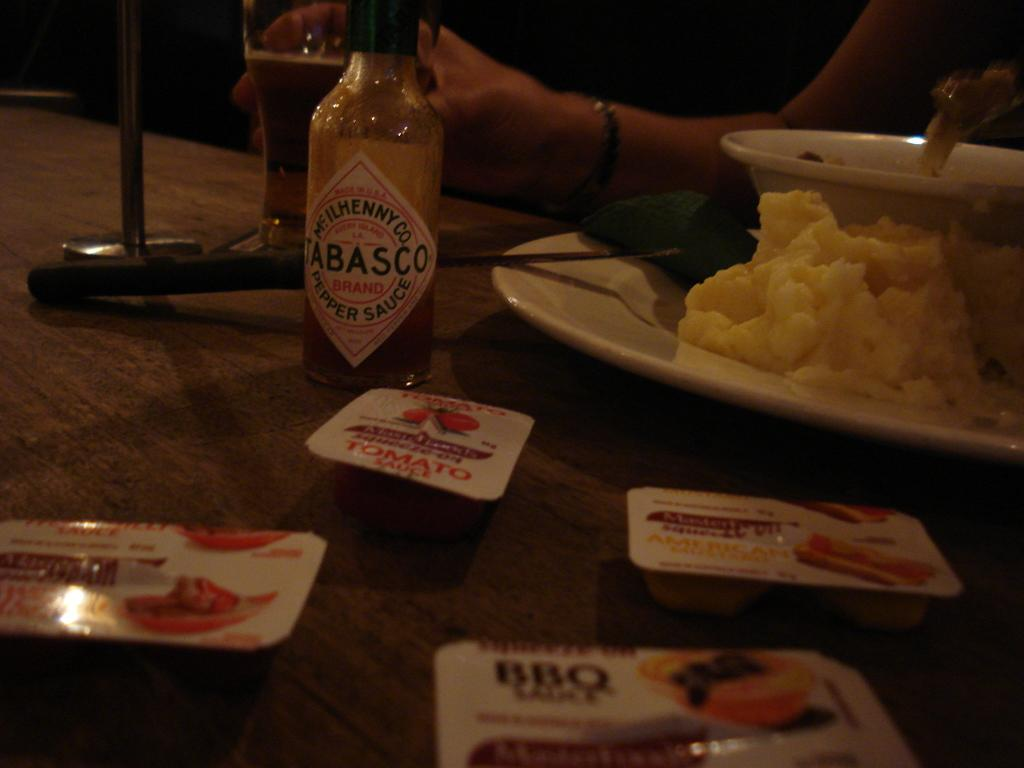<image>
Share a concise interpretation of the image provided. A table with a plate of scrambled eggs and Tabasco hot sauce. 